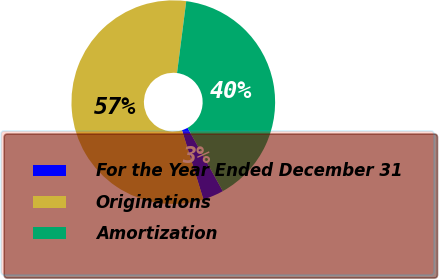Convert chart. <chart><loc_0><loc_0><loc_500><loc_500><pie_chart><fcel>For the Year Ended December 31<fcel>Originations<fcel>Amortization<nl><fcel>3.31%<fcel>56.81%<fcel>39.89%<nl></chart> 